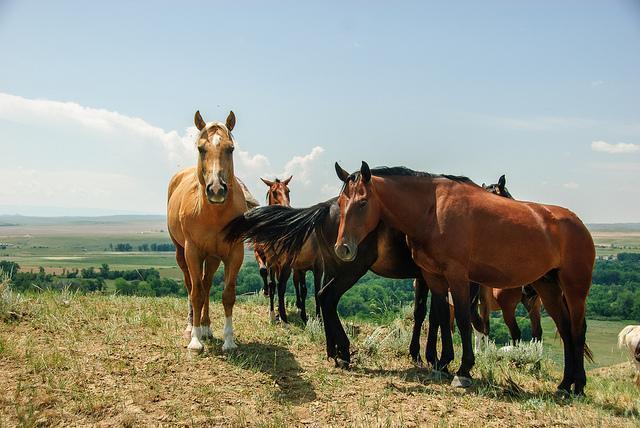What is above the horses?
From the following four choices, select the correct answer to address the question.
Options: Fly, kite, sky, dragon. Sky. 